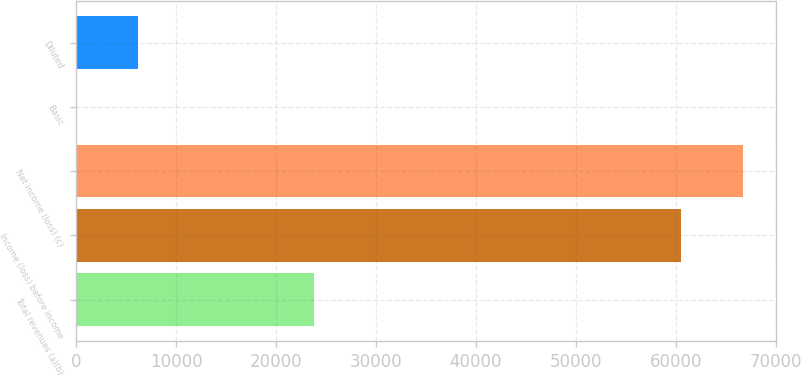Convert chart to OTSL. <chart><loc_0><loc_0><loc_500><loc_500><bar_chart><fcel>Total revenues (a)(b)<fcel>Income (loss) before income<fcel>Net income (loss) (c)<fcel>Basic<fcel>Diluted<nl><fcel>23758<fcel>60556<fcel>66719.6<fcel>22.95<fcel>6186.56<nl></chart> 